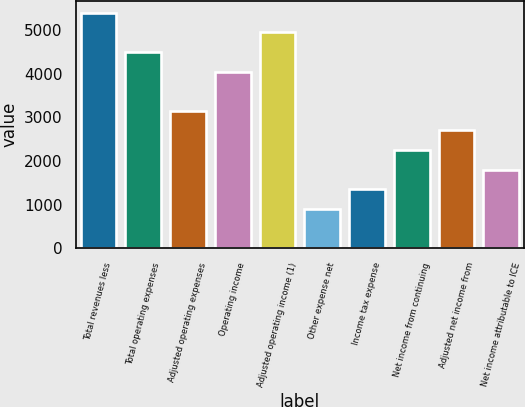<chart> <loc_0><loc_0><loc_500><loc_500><bar_chart><fcel>Total revenues less<fcel>Total operating expenses<fcel>Adjusted operating expenses<fcel>Operating income<fcel>Adjusted operating income (1)<fcel>Other expense net<fcel>Income tax expense<fcel>Net income from continuing<fcel>Adjusted net income from<fcel>Net income attributable to ICE<nl><fcel>5398.29<fcel>4498.97<fcel>3149.99<fcel>4049.31<fcel>4948.63<fcel>901.69<fcel>1351.35<fcel>2250.67<fcel>2700.33<fcel>1801.01<nl></chart> 